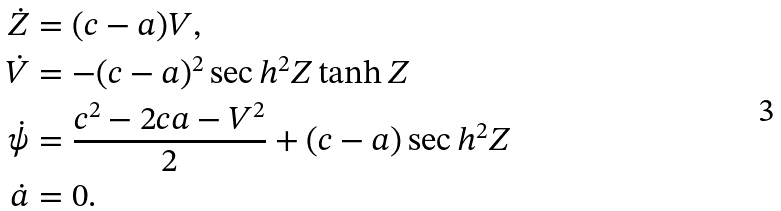<formula> <loc_0><loc_0><loc_500><loc_500>\dot { Z } & = ( c - a ) V , \\ \dot { V } & = - ( c - a ) ^ { 2 } \sec h ^ { 2 } { Z } \tanh { Z } \\ \dot { \psi } & = \frac { c ^ { 2 } - 2 c a - V ^ { 2 } } { 2 } + ( c - a ) \sec h ^ { 2 } { Z } \\ \dot { a } & = 0 .</formula> 